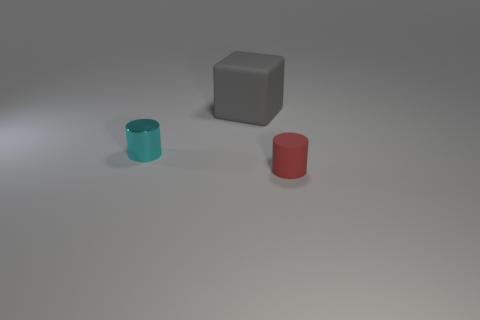Add 3 small green cylinders. How many objects exist? 6 Subtract all cylinders. How many objects are left? 1 Subtract 0 cyan cubes. How many objects are left? 3 Subtract all small things. Subtract all cyan things. How many objects are left? 0 Add 3 tiny objects. How many tiny objects are left? 5 Add 1 small cyan metallic cylinders. How many small cyan metallic cylinders exist? 2 